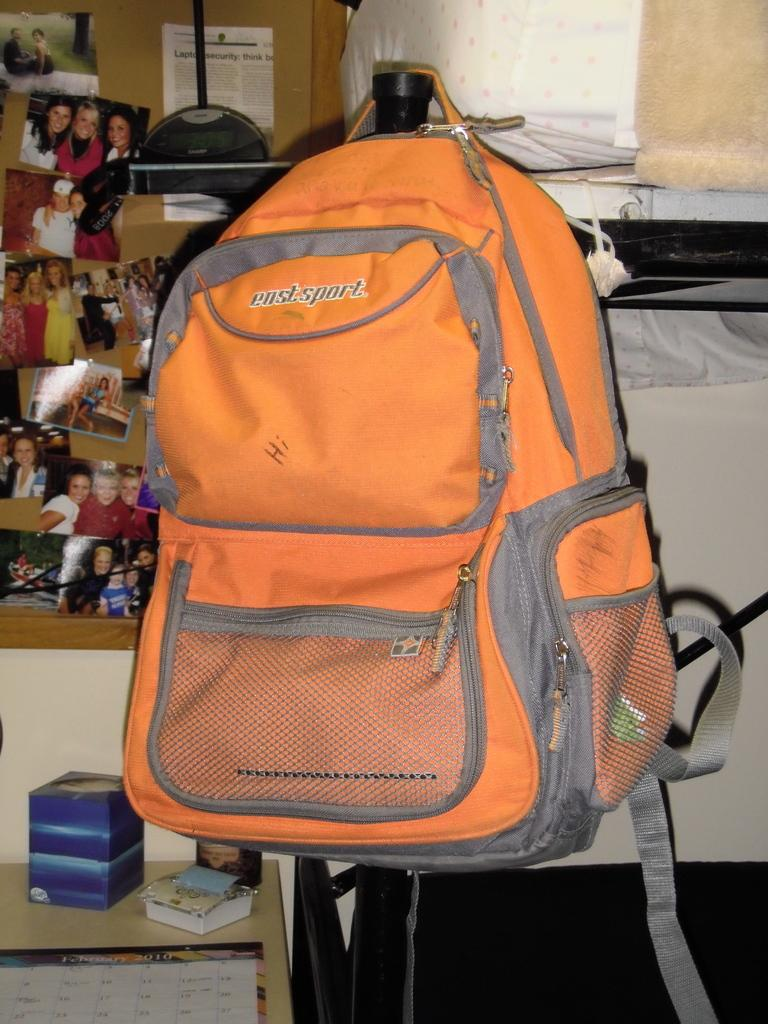What color is the bag that is visible in the image? The bag is orange in color. How is the bag positioned in the image? The bag is hanged on a pole. What can be seen on the board in the image? There are photos on a board in the image. What object is present in the image that might be used for storage? There is a box in the image. What is the purpose of the calendar in the image? The calendar on the table in the image is likely used for keeping track of dates and appointments. Can you describe the man's slip in the image? There is no man or slip present in the image. 